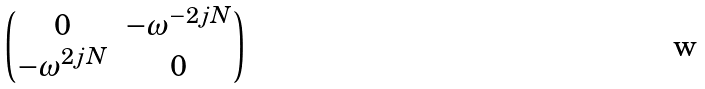<formula> <loc_0><loc_0><loc_500><loc_500>\begin{pmatrix} 0 & - \omega ^ { - 2 j N } \\ - \omega ^ { 2 j N } & 0 \end{pmatrix}</formula> 